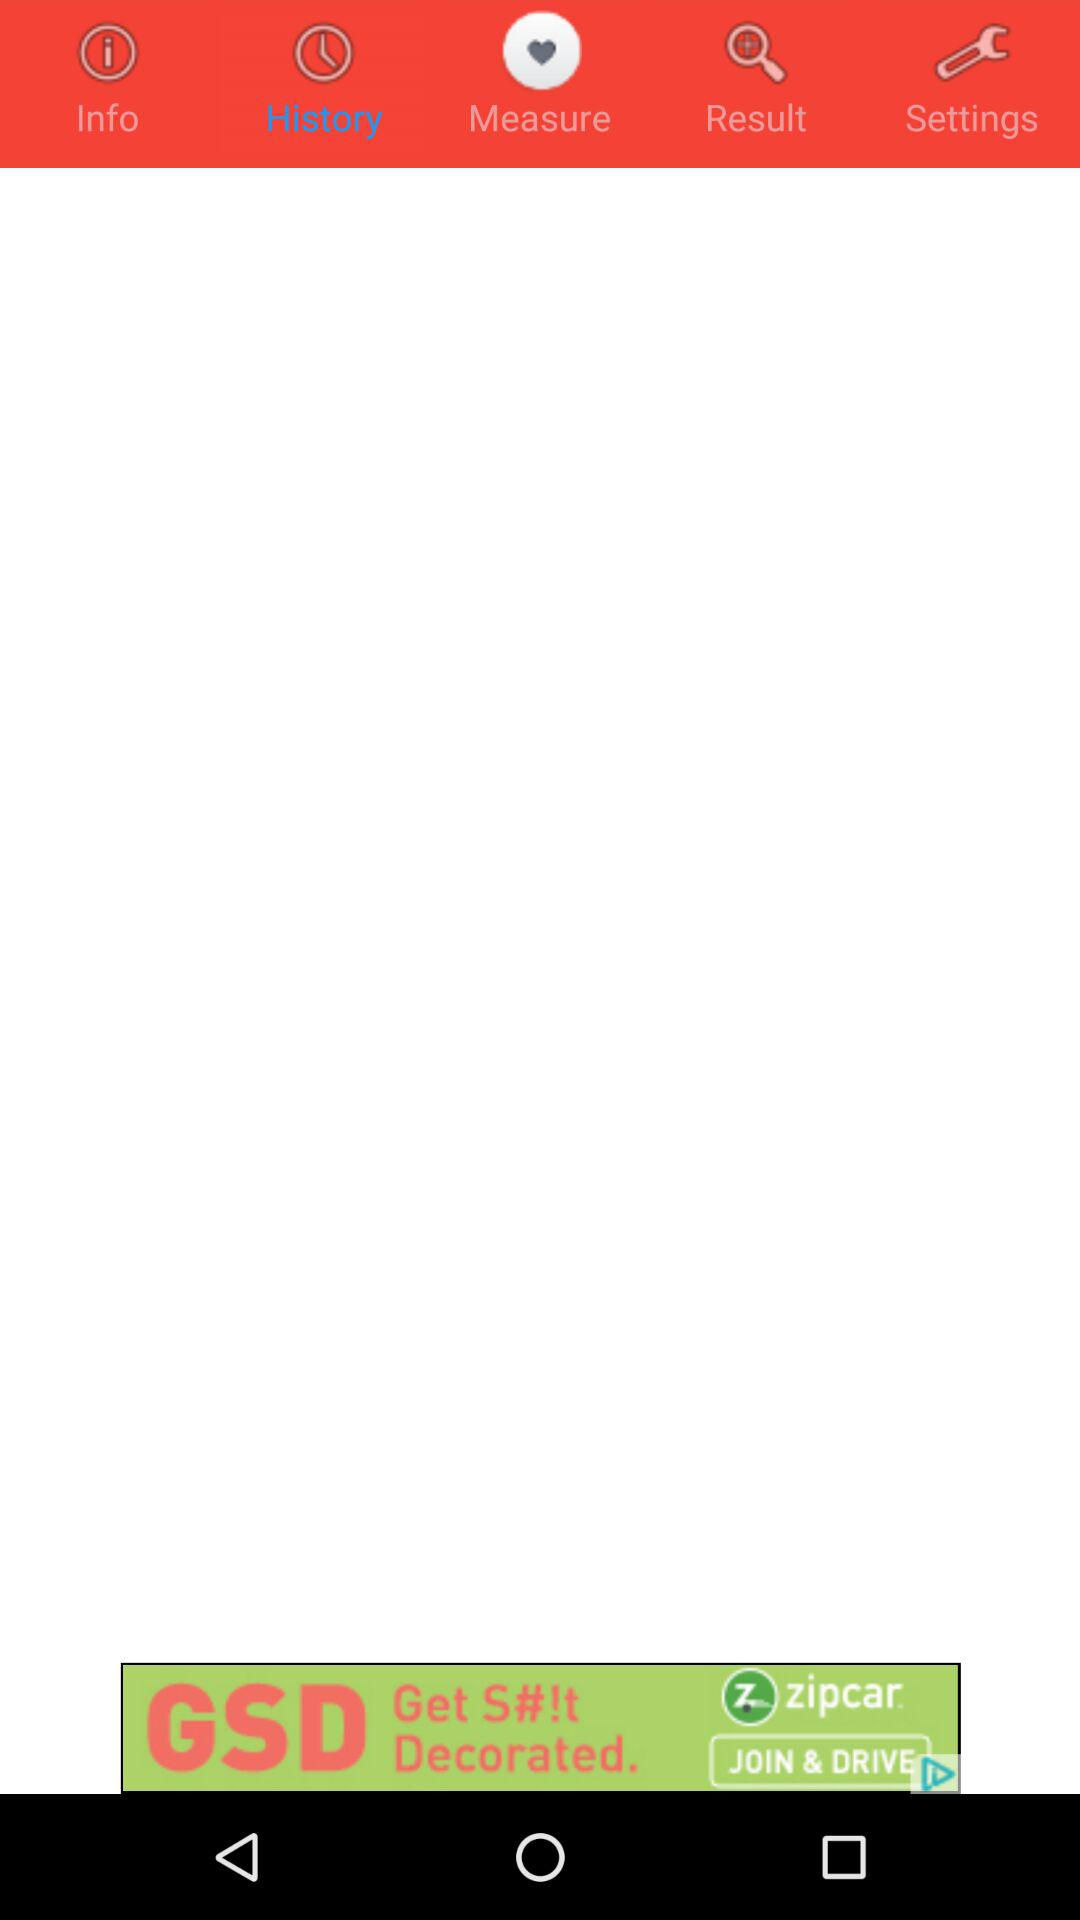Which tab is selected? The selected tab is "History". 